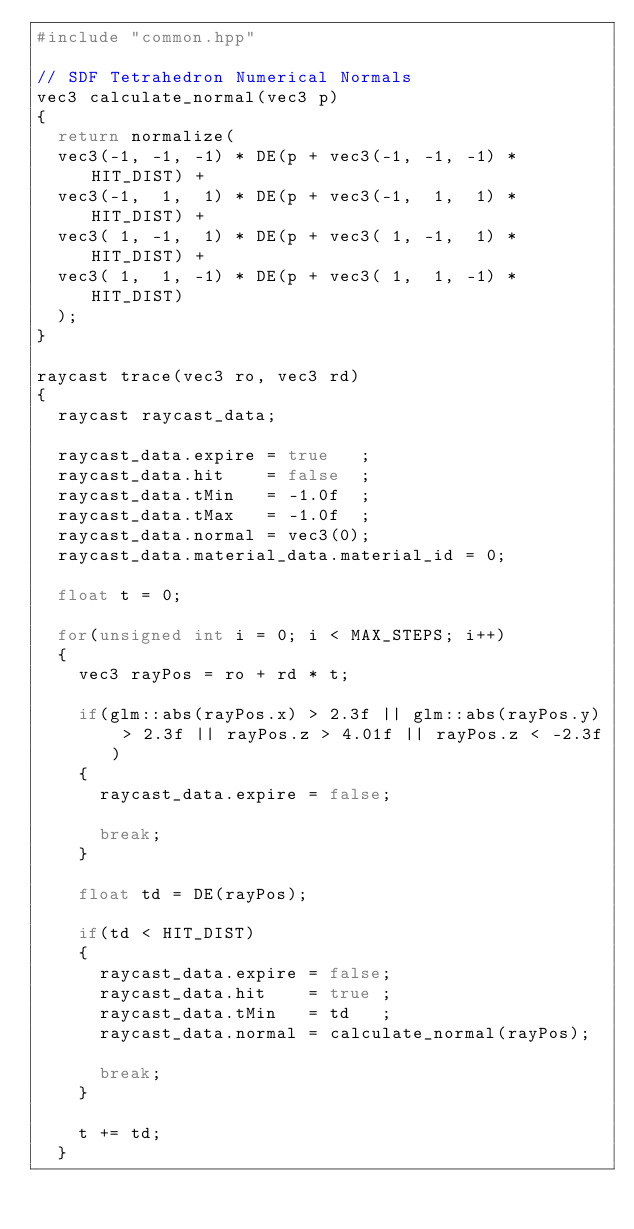Convert code to text. <code><loc_0><loc_0><loc_500><loc_500><_C++_>#include "common.hpp"

// SDF Tetrahedron Numerical Normals
vec3 calculate_normal(vec3 p)
{
	return normalize(
	vec3(-1, -1, -1) * DE(p + vec3(-1, -1, -1) * HIT_DIST) +
	vec3(-1,  1,  1) * DE(p + vec3(-1,  1,  1) * HIT_DIST) +
	vec3( 1, -1,  1) * DE(p + vec3( 1, -1,  1) * HIT_DIST) +
	vec3( 1,  1, -1) * DE(p + vec3( 1,  1, -1) * HIT_DIST)
	);
}

raycast trace(vec3 ro, vec3 rd)
{
	raycast raycast_data;

	raycast_data.expire = true   ;
	raycast_data.hit    = false  ;
	raycast_data.tMin   = -1.0f  ;
	raycast_data.tMax   = -1.0f  ;
	raycast_data.normal = vec3(0);
	raycast_data.material_data.material_id = 0;

	float t = 0;

	for(unsigned int i = 0; i < MAX_STEPS; i++)
	{
		vec3 rayPos = ro + rd * t;

		if(glm::abs(rayPos.x) > 2.3f || glm::abs(rayPos.y) > 2.3f || rayPos.z > 4.01f || rayPos.z < -2.3f)
		{
			raycast_data.expire = false;

			break;
		}

		float td = DE(rayPos);

		if(td < HIT_DIST)
		{
			raycast_data.expire = false;
			raycast_data.hit    = true ;
			raycast_data.tMin   = td   ;
			raycast_data.normal = calculate_normal(rayPos);

			break;
		}

		t += td;
	}
</code> 